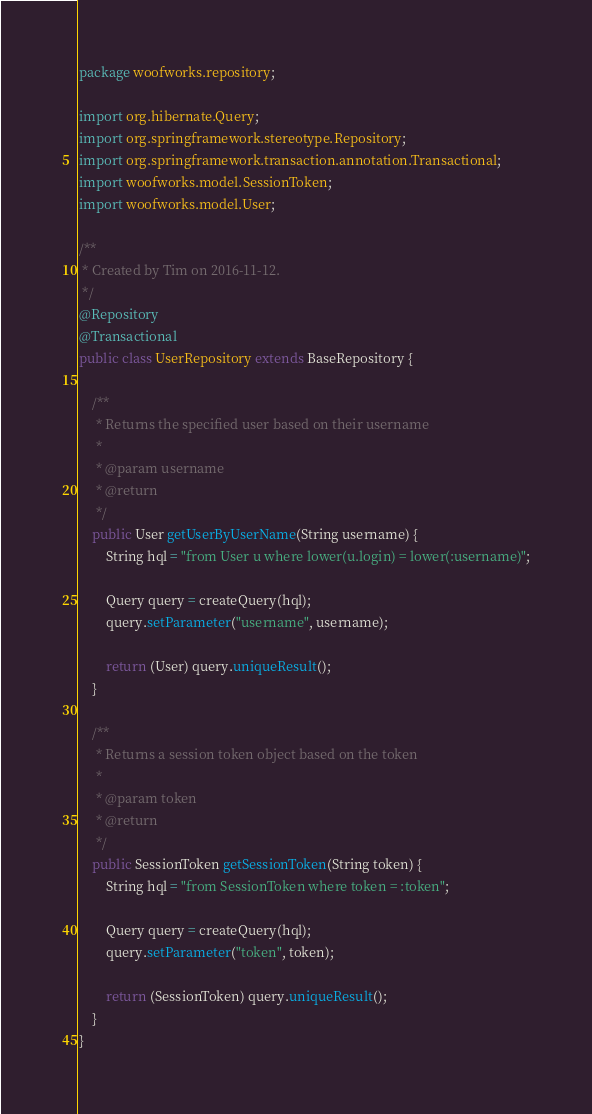Convert code to text. <code><loc_0><loc_0><loc_500><loc_500><_Java_>package woofworks.repository;

import org.hibernate.Query;
import org.springframework.stereotype.Repository;
import org.springframework.transaction.annotation.Transactional;
import woofworks.model.SessionToken;
import woofworks.model.User;

/**
 * Created by Tim on 2016-11-12.
 */
@Repository
@Transactional
public class UserRepository extends BaseRepository {

    /**
     * Returns the specified user based on their username
     *
     * @param username
     * @return
     */
    public User getUserByUserName(String username) {
        String hql = "from User u where lower(u.login) = lower(:username)";

        Query query = createQuery(hql);
        query.setParameter("username", username);

        return (User) query.uniqueResult();
    }

    /**
     * Returns a session token object based on the token
     *
     * @param token
     * @return
     */
    public SessionToken getSessionToken(String token) {
        String hql = "from SessionToken where token = :token";

        Query query = createQuery(hql);
        query.setParameter("token", token);

        return (SessionToken) query.uniqueResult();
    }
}
</code> 